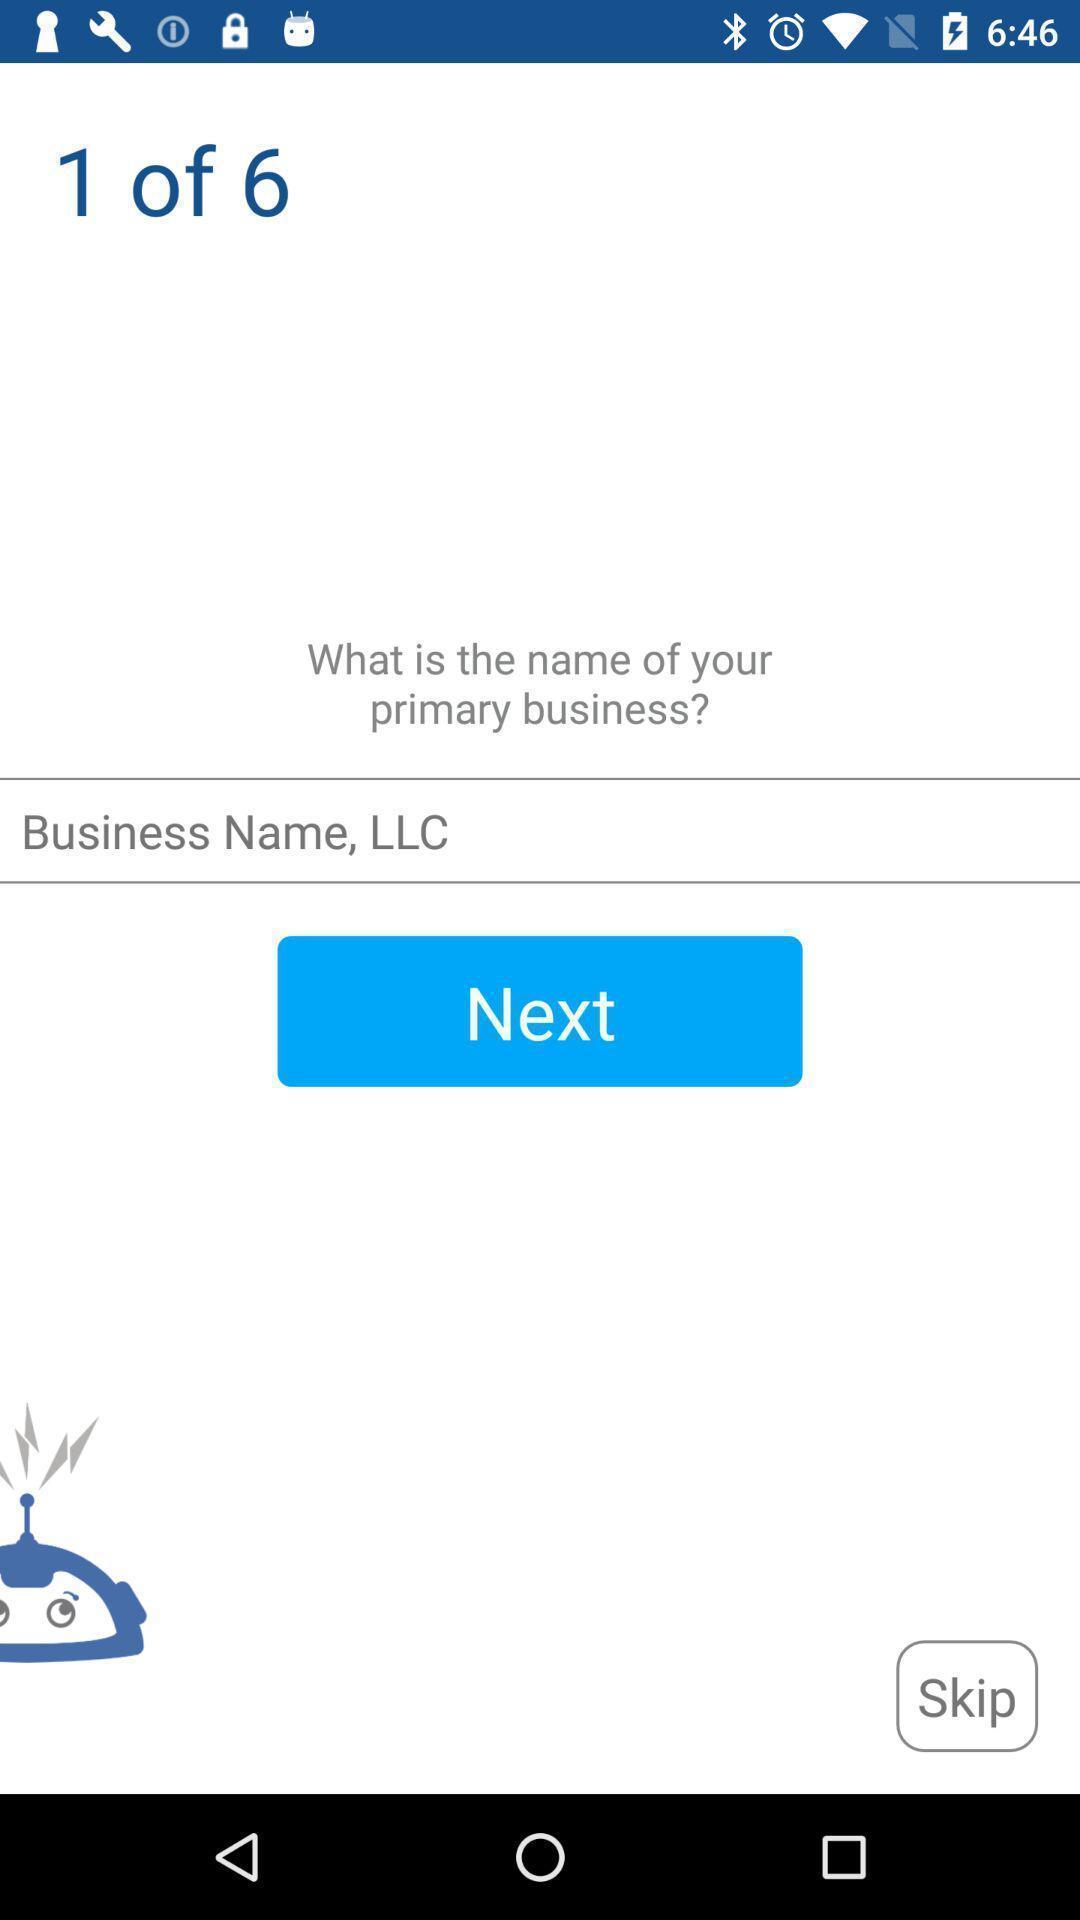Tell me what you see in this picture. Page showing to enter business name. 